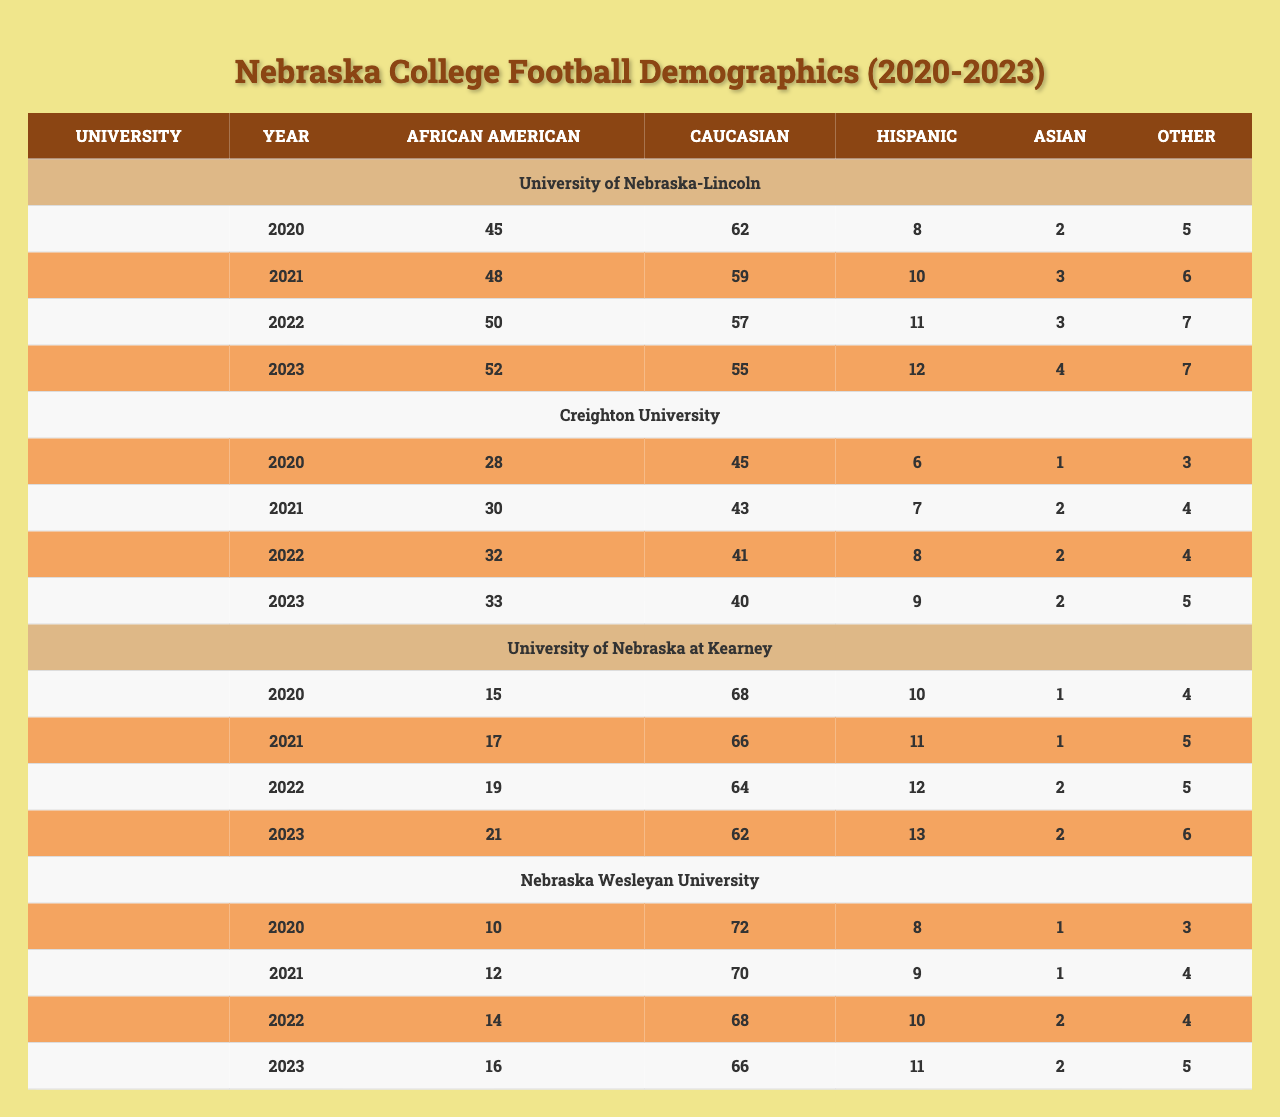What was the total number of African American players at the University of Nebraska-Lincoln in 2021? The number of African American players at the University of Nebraska-Lincoln in 2021 is directly provided in the table as 48.
Answer: 48 Which university had the highest number of Hispanic players in 2023? Checking the table for the Hispanic player counts in 2023: University of Nebraska-Lincoln had 12, Creighton University had 9, University of Nebraska at Kearney had 13, and Nebraska Wesleyan University had 11. The highest was at the University of Nebraska at Kearney with 13 players.
Answer: University of Nebraska at Kearney What is the percentage increase of African American players at Creighton University from 2020 to 2023? The number of African American players in 2020 was 28, and in 2023 it was 33. The increase is 33 - 28 = 5. The percentage increase is (5 / 28) * 100 = 17.86%.
Answer: 17.86% Is there an increase in the number of Asian players at Nebraska Wesleyan University from 2020 to 2023? In 2020, there was 1 Asian player, and in 2023 there were 2. Since 2 is greater than 1, this confirms that there was an increase.
Answer: Yes What was the average number of Caucasian players across all universities in 2022? Adding the Caucasian players in 2022: Nebraska-Lincoln (57) + Creighton University (41) + Kearney (64) + Nebraska Wesleyan (68) = 230. There are 4 universities, so the average is 230/4 = 57.5.
Answer: 57.5 How many more Caucasian players were there at the University of Nebraska-Lincoln in 2020 compared to 2023? In 2020, there were 62 Caucasian players and in 2023, there were 55. The difference is 62 - 55 = 7.
Answer: 7 Which university had the least number of African American players in 2020? Looking at the African American player counts for 2020: University of Nebraska-Lincoln had 45, Creighton had 28, Kearney had 15, and Nebraska Wesleyan had 10. The least number is at Nebraska Wesleyan with 10.
Answer: Nebraska Wesleyan University What is the total number of 'Other' demographics across all universities in the year 2021? Adding the 'Other' counts for 2021 from all universities: University of Nebraska-Lincoln (6) + Creighton University (4) + University of Nebraska at Kearney (5) + Nebraska Wesleyan (4) = 19.
Answer: 19 In which year did the University of Nebraska-Lincoln see the highest representation of Hispanic players? Checking the counts for Hispanic players from 2020 to 2023: 8, 10, 11, 12. The highest representation was in 2023 with 12 players.
Answer: 2023 What is the overall trend for African American players at University of Nebraska-Lincoln from 2020 to 2023? The counts for years are: 45, 48, 50, and 52. This shows a consistent increase each year, indicating an upward trend.
Answer: Upward trend Which university had the largest drop in the number of Caucasian players from 2020 to 2023? Observing the change: University of Nebraska-Lincoln went from 62 to 55 (drop of 7), Creighton from 45 to 40 (drop of 5), Kearney from 68 to 62 (drop of 6), and Nebraska Wesleyan from 72 to 66 (drop of 6). The largest drop was at the University of Nebraska-Lincoln with a drop of 7.
Answer: University of Nebraska-Lincoln 